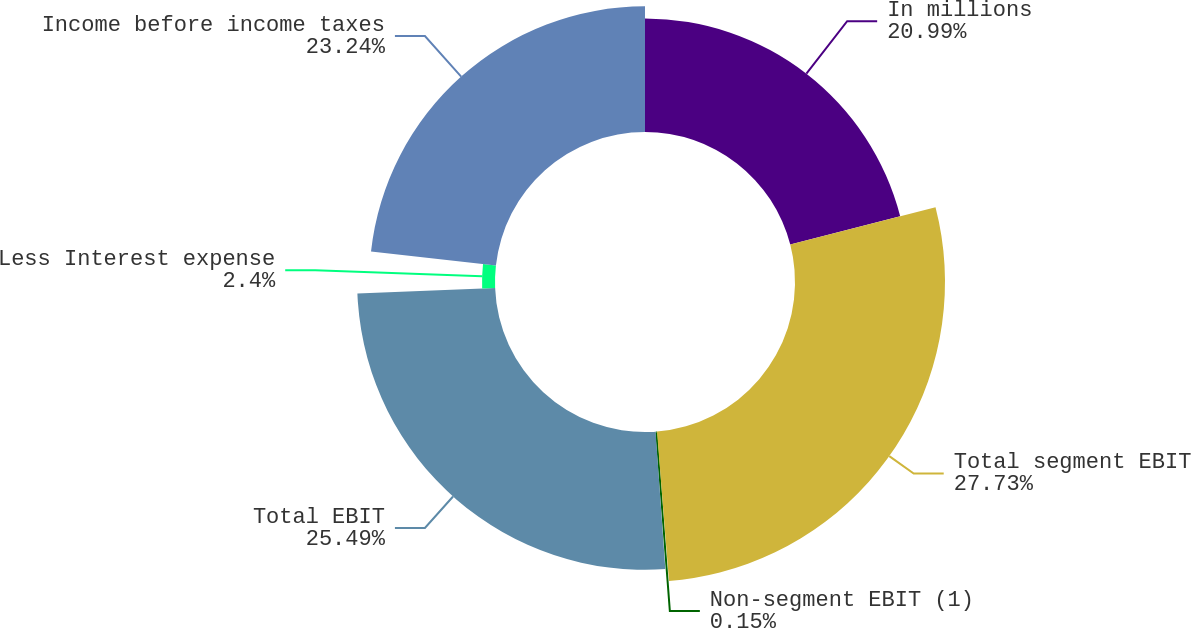<chart> <loc_0><loc_0><loc_500><loc_500><pie_chart><fcel>In millions<fcel>Total segment EBIT<fcel>Non-segment EBIT (1)<fcel>Total EBIT<fcel>Less Interest expense<fcel>Income before income taxes<nl><fcel>20.99%<fcel>27.74%<fcel>0.15%<fcel>25.49%<fcel>2.4%<fcel>23.24%<nl></chart> 